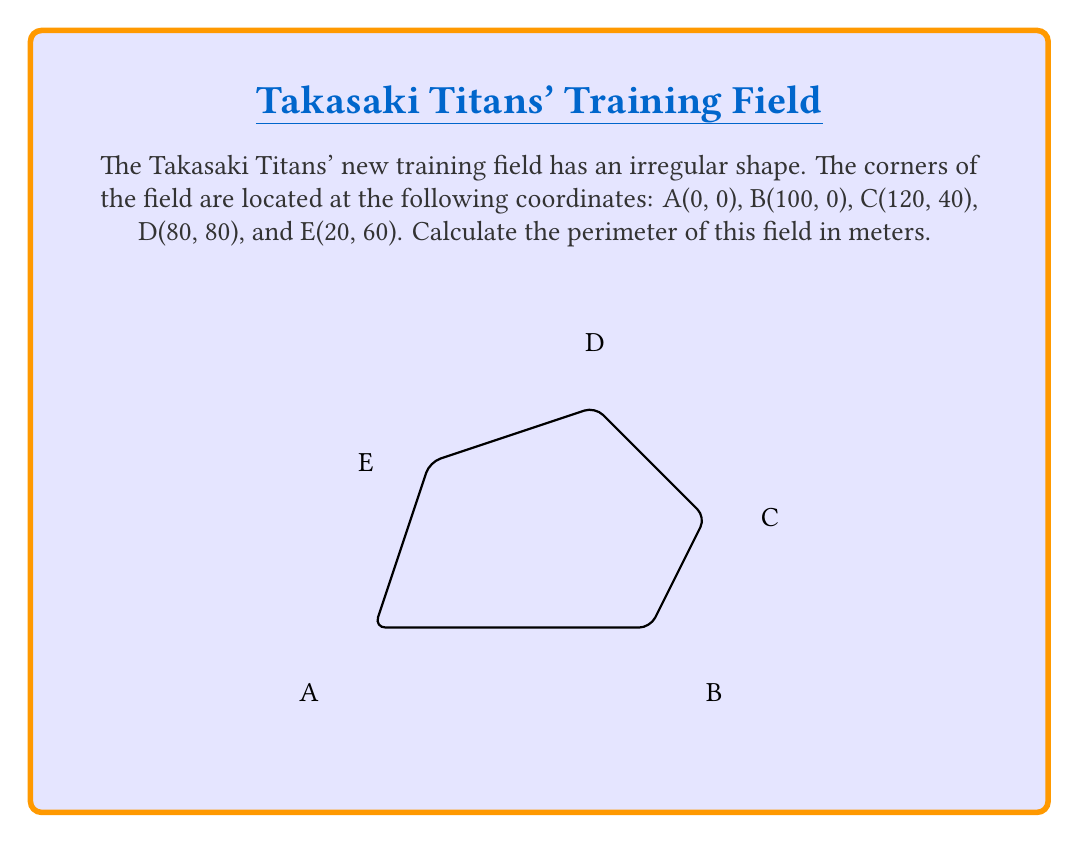Teach me how to tackle this problem. To find the perimeter of the irregular field, we need to calculate the distance between each pair of consecutive points and sum them up. We'll use the distance formula:

$$d = \sqrt{(x_2 - x_1)^2 + (y_2 - y_1)^2}$$

Let's calculate each side length:

1. AB: $d_{AB} = \sqrt{(100 - 0)^2 + (0 - 0)^2} = 100$ m

2. BC: $d_{BC} = \sqrt{(120 - 100)^2 + (40 - 0)^2} = \sqrt{400 + 1600} = \sqrt{2000} = 20\sqrt{5}$ m

3. CD: $d_{CD} = \sqrt{(80 - 120)^2 + (80 - 40)^2} = \sqrt{1600 + 1600} = \sqrt{3200} = 40\sqrt{2}$ m

4. DE: $d_{DE} = \sqrt{(20 - 80)^2 + (60 - 80)^2} = \sqrt{3600 + 400} = \sqrt{4000} = 20\sqrt{10}$ m

5. EA: $d_{EA} = \sqrt{(0 - 20)^2 + (0 - 60)^2} = \sqrt{400 + 3600} = \sqrt{4000} = 20\sqrt{10}$ m

Now, sum up all the side lengths to get the perimeter:

$$\text{Perimeter} = 100 + 20\sqrt{5} + 40\sqrt{2} + 20\sqrt{10} + 20\sqrt{10}$$

$$= 100 + 20\sqrt{5} + 40\sqrt{2} + 40\sqrt{10}$$

This is the exact perimeter in meters.
Answer: $100 + 20\sqrt{5} + 40\sqrt{2} + 40\sqrt{10}$ m 